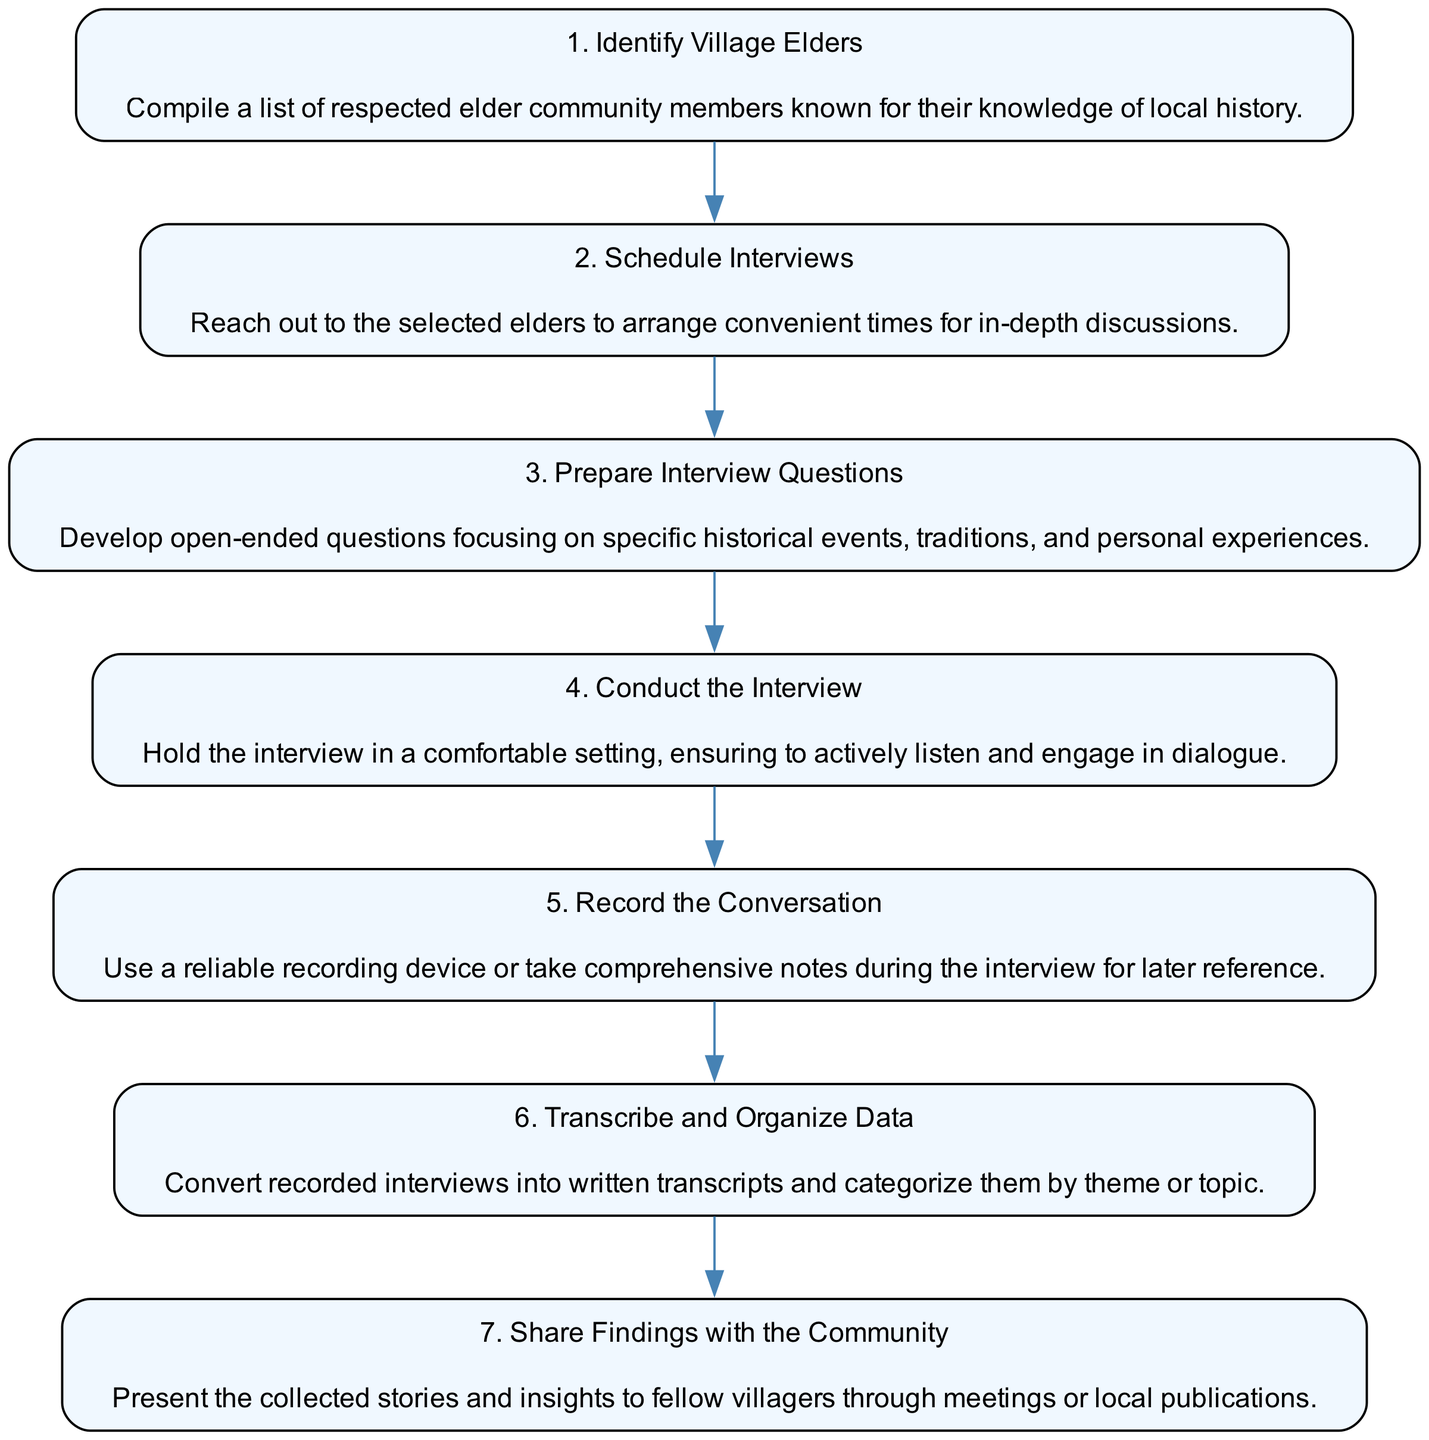What is the first step in the flow chart? The first step is labeled as "1. Identify Village Elders," which indicates it is the starting point of the process for conducting oral histories.
Answer: Identify Village Elders How many steps are there in the flow chart? By counting each step listed from Identify Village Elders to Share Findings with the Community, we find a total of 7 steps represented in the diagram.
Answer: 7 What is the last step in the flow chart? The last step is marked as "7. Share Findings with the Community," which concludes the process outlined in the flow chart.
Answer: Share Findings with the Community Which step comes after "Conduct the Interview"? Following "Conduct the Interview," the next step is "Record the Conversation," which shows the progression in the oral history process.
Answer: Record the Conversation What type of questions should be prepared? The diagram specifies that interview questions should be "open-ended" to encourage detailed responses and discussions with elders.
Answer: open-ended questions Explain how the steps are connected from "Schedule Interviews" to "Share Findings with the Community." The connection begins with "Schedule Interviews," which leads to "Prepare Interview Questions." After that, once the interview is conducted, it goes to "Record the Conversation," followed by "Transcribe and Organize Data," and finally culminates in "Share Findings with the Community," showcasing the process flow among these steps.
Answer: They are connected sequentially What must be done before conducting the interview? Before conducting the interview, it's crucial to "Prepare Interview Questions," ensuring that the interviewer is ready with specific queries to ask the elders.
Answer: Prepare Interview Questions 